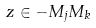<formula> <loc_0><loc_0><loc_500><loc_500>z \in - M _ { j } M _ { k }</formula> 